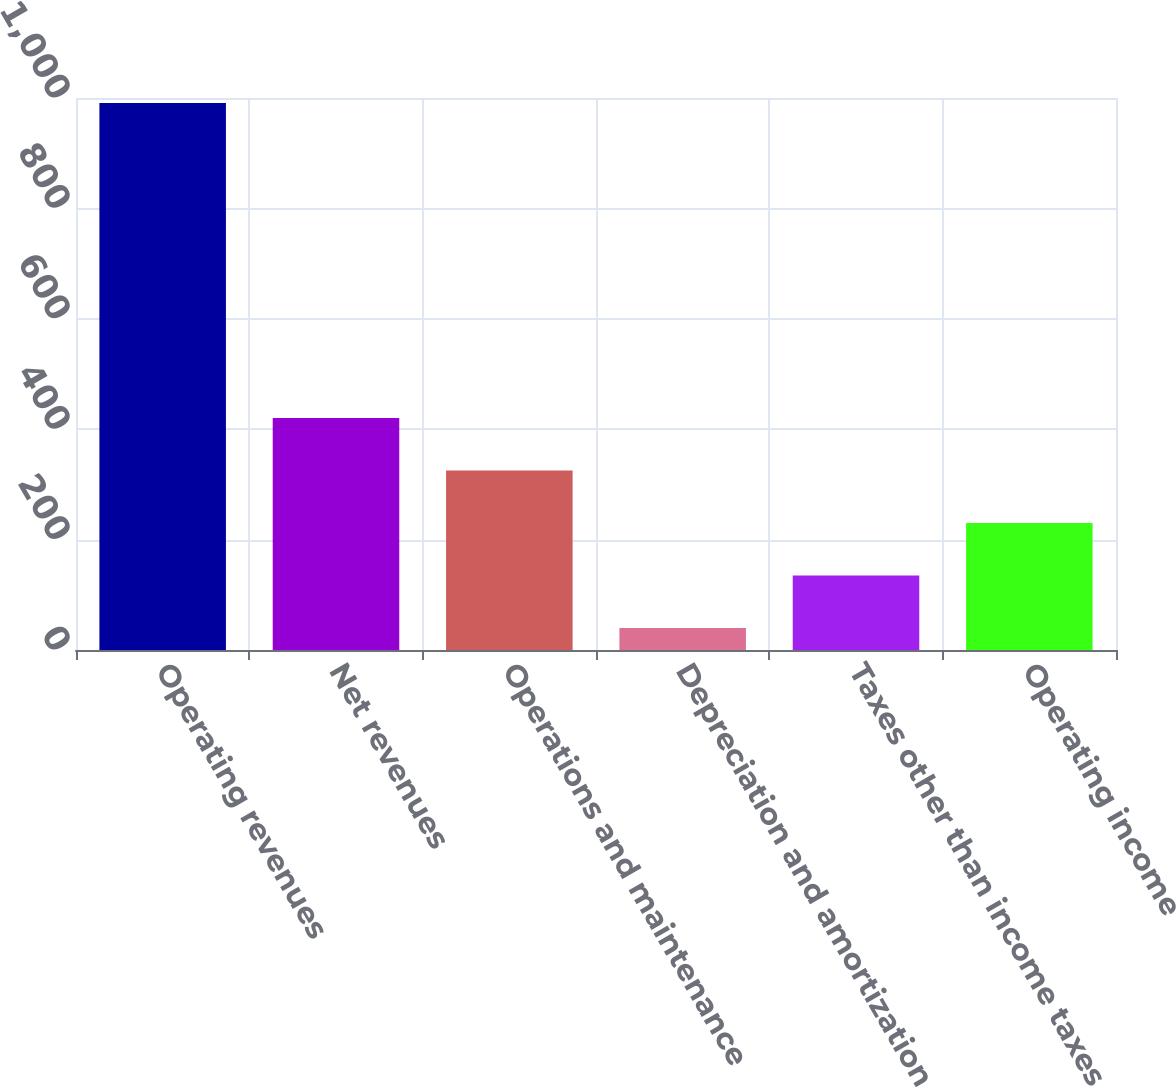<chart> <loc_0><loc_0><loc_500><loc_500><bar_chart><fcel>Operating revenues<fcel>Net revenues<fcel>Operations and maintenance<fcel>Depreciation and amortization<fcel>Taxes other than income taxes<fcel>Operating income<nl><fcel>991<fcel>420.4<fcel>325.3<fcel>40<fcel>135.1<fcel>230.2<nl></chart> 